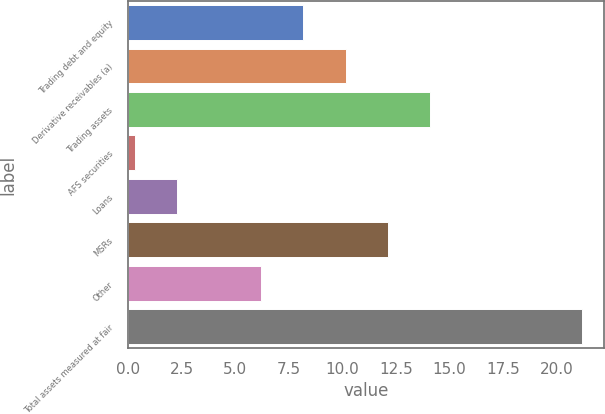<chart> <loc_0><loc_0><loc_500><loc_500><bar_chart><fcel>Trading debt and equity<fcel>Derivative receivables (a)<fcel>Trading assets<fcel>AFS securities<fcel>Loans<fcel>MSRs<fcel>Other<fcel>Total assets measured at fair<nl><fcel>8.18<fcel>10.15<fcel>14.09<fcel>0.3<fcel>2.27<fcel>12.12<fcel>6.21<fcel>21.17<nl></chart> 